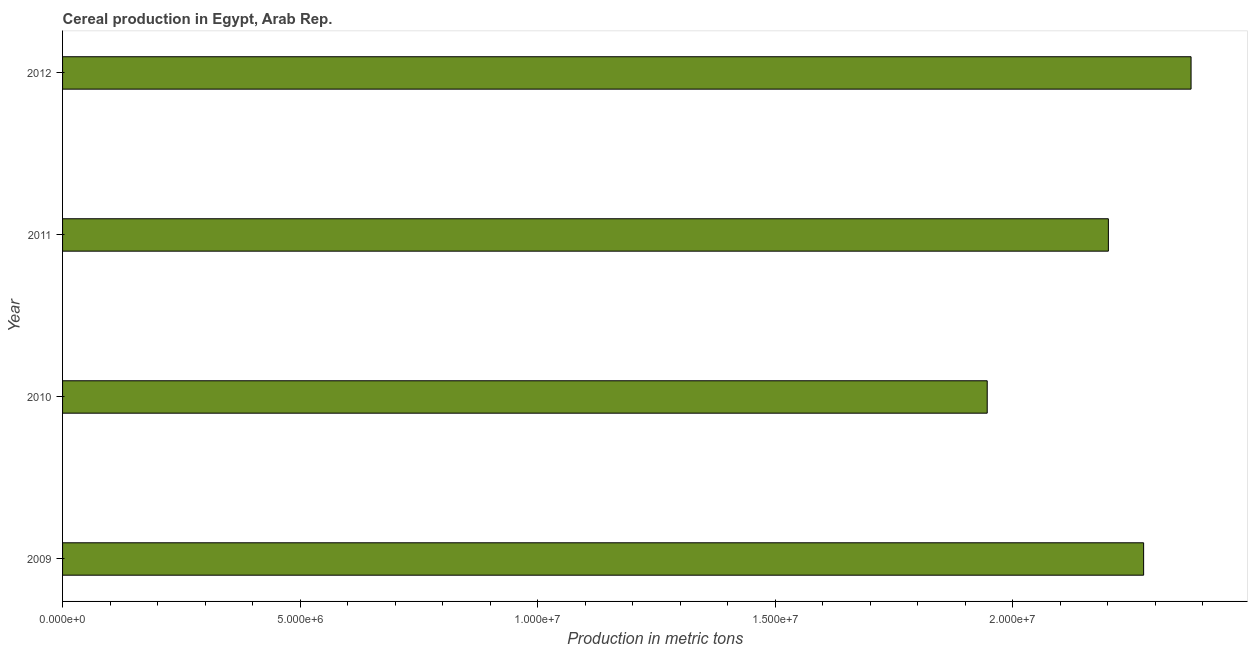Does the graph contain any zero values?
Offer a terse response. No. Does the graph contain grids?
Give a very brief answer. No. What is the title of the graph?
Make the answer very short. Cereal production in Egypt, Arab Rep. What is the label or title of the X-axis?
Make the answer very short. Production in metric tons. What is the label or title of the Y-axis?
Provide a short and direct response. Year. What is the cereal production in 2011?
Keep it short and to the point. 2.20e+07. Across all years, what is the maximum cereal production?
Give a very brief answer. 2.38e+07. Across all years, what is the minimum cereal production?
Keep it short and to the point. 1.95e+07. In which year was the cereal production minimum?
Give a very brief answer. 2010. What is the sum of the cereal production?
Give a very brief answer. 8.80e+07. What is the difference between the cereal production in 2011 and 2012?
Your response must be concise. -1.74e+06. What is the average cereal production per year?
Make the answer very short. 2.20e+07. What is the median cereal production?
Offer a very short reply. 2.24e+07. What is the ratio of the cereal production in 2011 to that in 2012?
Give a very brief answer. 0.93. Is the cereal production in 2010 less than that in 2012?
Your answer should be compact. Yes. Is the difference between the cereal production in 2009 and 2011 greater than the difference between any two years?
Keep it short and to the point. No. What is the difference between the highest and the second highest cereal production?
Provide a short and direct response. 9.99e+05. Is the sum of the cereal production in 2011 and 2012 greater than the maximum cereal production across all years?
Your response must be concise. Yes. What is the difference between the highest and the lowest cereal production?
Offer a terse response. 4.29e+06. In how many years, is the cereal production greater than the average cereal production taken over all years?
Make the answer very short. 3. What is the difference between two consecutive major ticks on the X-axis?
Your answer should be compact. 5.00e+06. Are the values on the major ticks of X-axis written in scientific E-notation?
Provide a succinct answer. Yes. What is the Production in metric tons in 2009?
Offer a very short reply. 2.28e+07. What is the Production in metric tons in 2010?
Your answer should be compact. 1.95e+07. What is the Production in metric tons of 2011?
Your response must be concise. 2.20e+07. What is the Production in metric tons in 2012?
Offer a very short reply. 2.38e+07. What is the difference between the Production in metric tons in 2009 and 2010?
Offer a terse response. 3.29e+06. What is the difference between the Production in metric tons in 2009 and 2011?
Give a very brief answer. 7.42e+05. What is the difference between the Production in metric tons in 2009 and 2012?
Offer a very short reply. -9.99e+05. What is the difference between the Production in metric tons in 2010 and 2011?
Keep it short and to the point. -2.55e+06. What is the difference between the Production in metric tons in 2010 and 2012?
Give a very brief answer. -4.29e+06. What is the difference between the Production in metric tons in 2011 and 2012?
Make the answer very short. -1.74e+06. What is the ratio of the Production in metric tons in 2009 to that in 2010?
Ensure brevity in your answer.  1.17. What is the ratio of the Production in metric tons in 2009 to that in 2011?
Offer a terse response. 1.03. What is the ratio of the Production in metric tons in 2009 to that in 2012?
Provide a short and direct response. 0.96. What is the ratio of the Production in metric tons in 2010 to that in 2011?
Your answer should be compact. 0.88. What is the ratio of the Production in metric tons in 2010 to that in 2012?
Keep it short and to the point. 0.82. What is the ratio of the Production in metric tons in 2011 to that in 2012?
Provide a succinct answer. 0.93. 